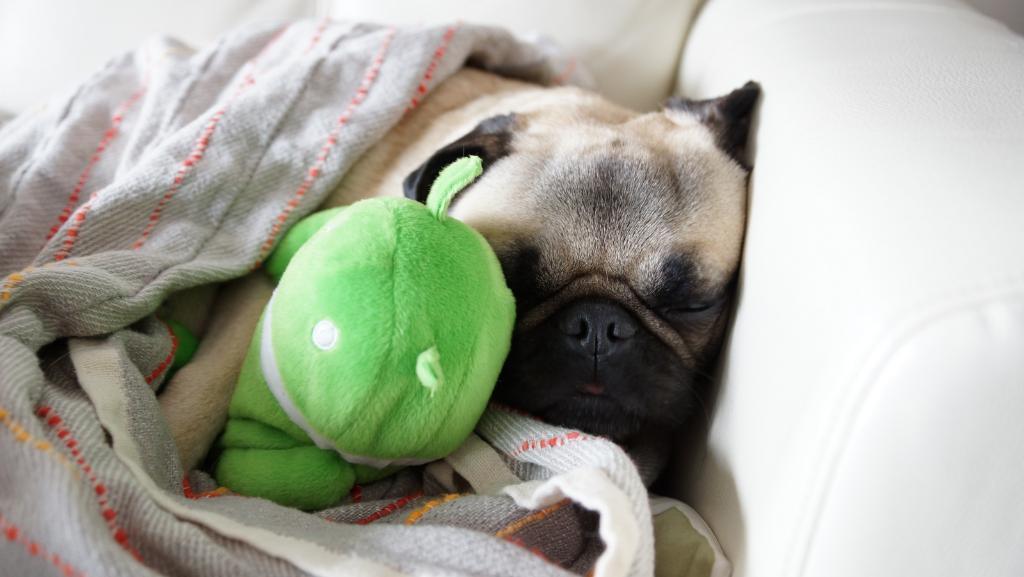How would you summarize this image in a sentence or two? In this image we can see that a dog sleeping on a couch and it is sleeping with a soft toy and we can also see that a blanket is covered on the dog. 